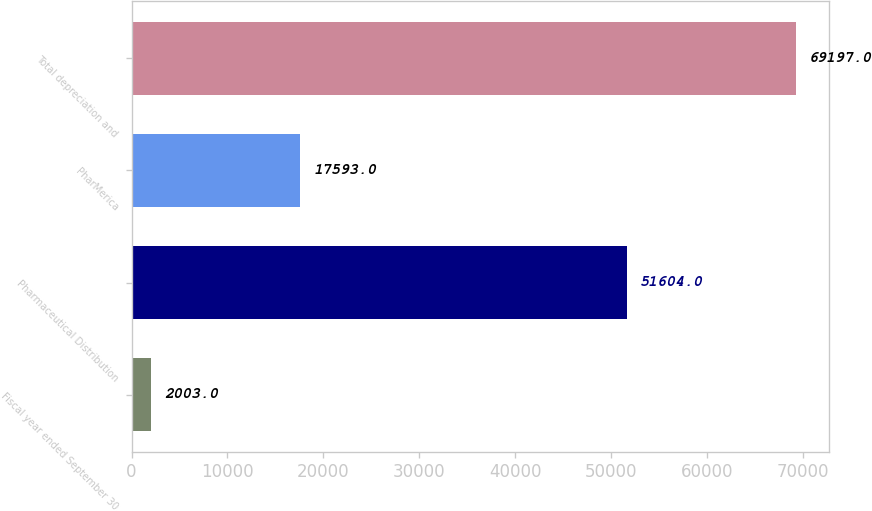Convert chart to OTSL. <chart><loc_0><loc_0><loc_500><loc_500><bar_chart><fcel>Fiscal year ended September 30<fcel>Pharmaceutical Distribution<fcel>PharMerica<fcel>Total depreciation and<nl><fcel>2003<fcel>51604<fcel>17593<fcel>69197<nl></chart> 